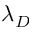Convert formula to latex. <formula><loc_0><loc_0><loc_500><loc_500>\lambda _ { D }</formula> 